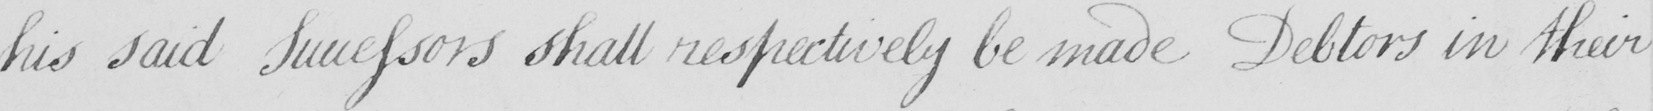Transcribe the text shown in this historical manuscript line. his said Successors shall respectively be made Debtors in their 